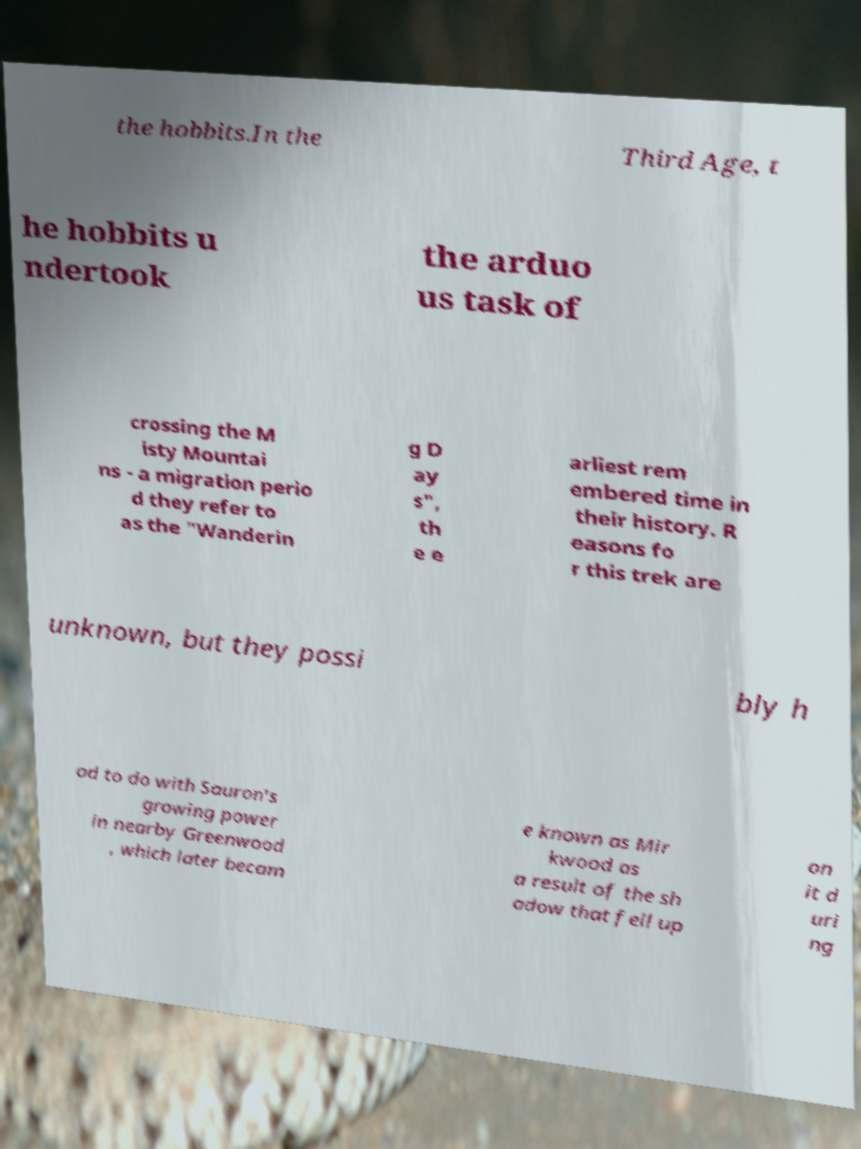Can you accurately transcribe the text from the provided image for me? the hobbits.In the Third Age, t he hobbits u ndertook the arduo us task of crossing the M isty Mountai ns - a migration perio d they refer to as the "Wanderin g D ay s", th e e arliest rem embered time in their history. R easons fo r this trek are unknown, but they possi bly h ad to do with Sauron's growing power in nearby Greenwood , which later becam e known as Mir kwood as a result of the sh adow that fell up on it d uri ng 